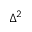<formula> <loc_0><loc_0><loc_500><loc_500>\Delta ^ { 2 }</formula> 